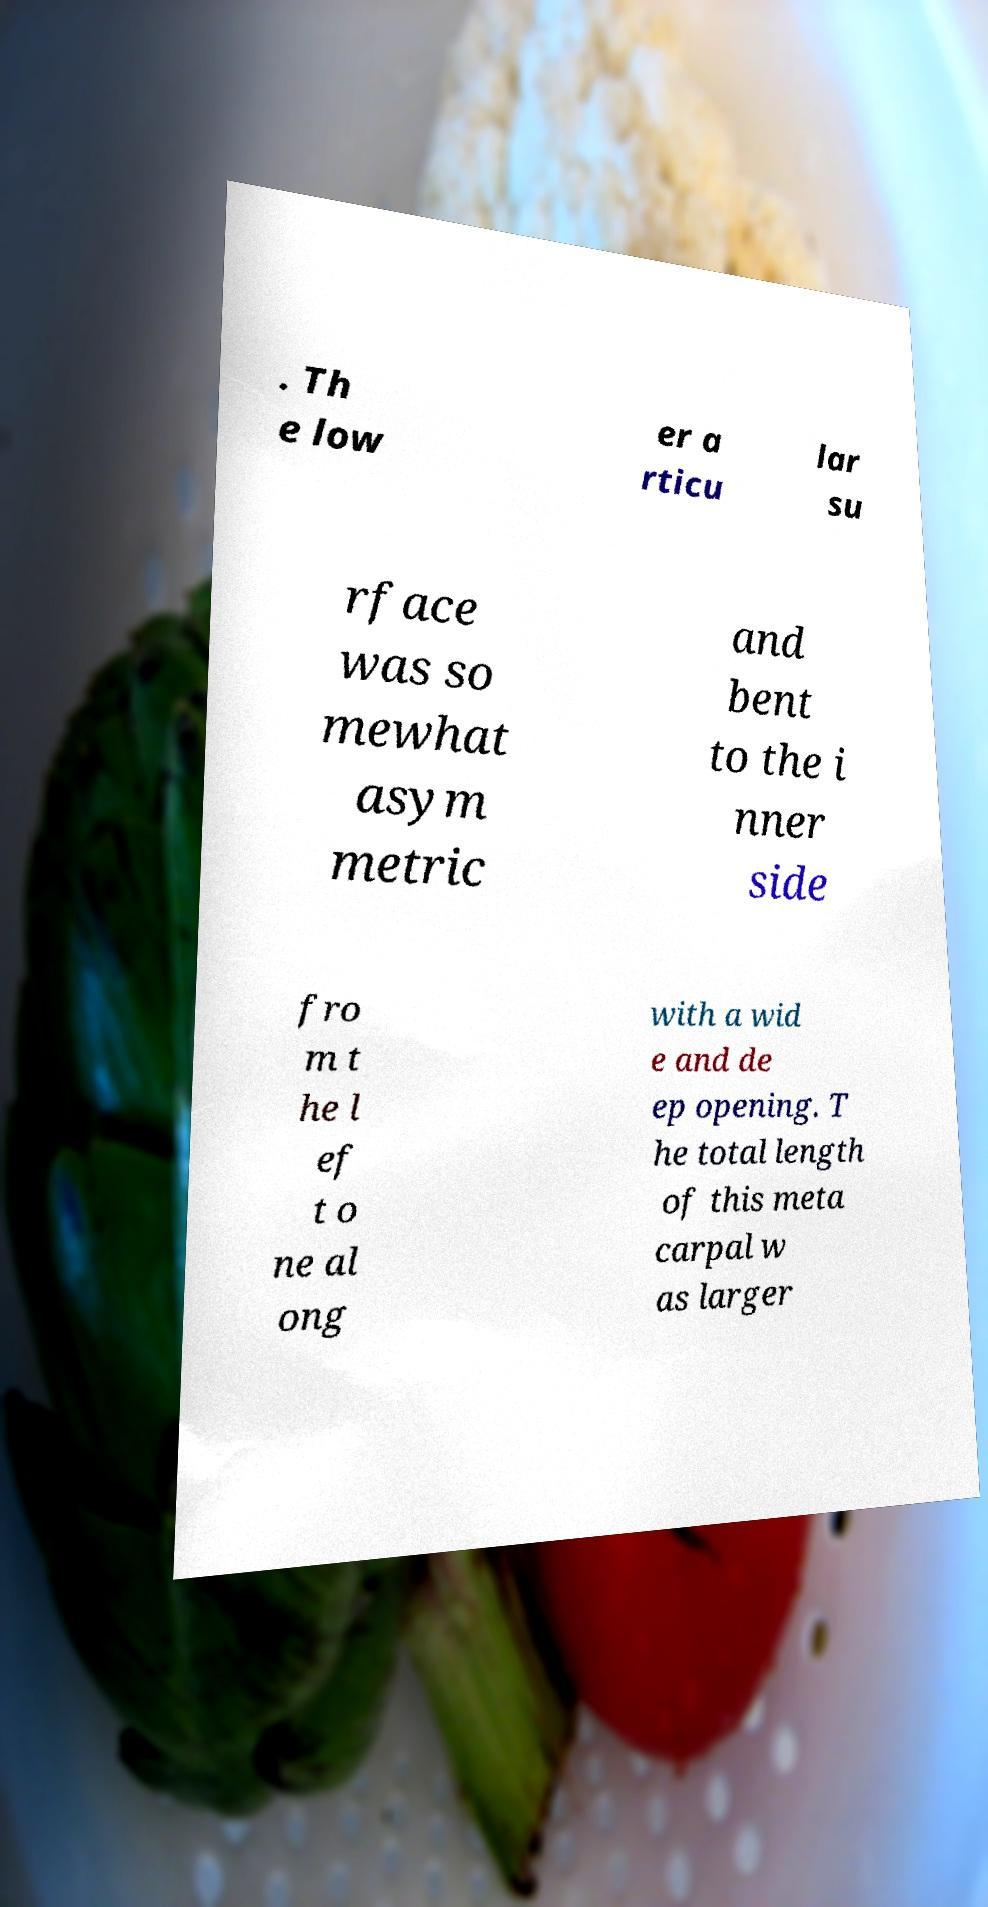Can you read and provide the text displayed in the image?This photo seems to have some interesting text. Can you extract and type it out for me? . Th e low er a rticu lar su rface was so mewhat asym metric and bent to the i nner side fro m t he l ef t o ne al ong with a wid e and de ep opening. T he total length of this meta carpal w as larger 